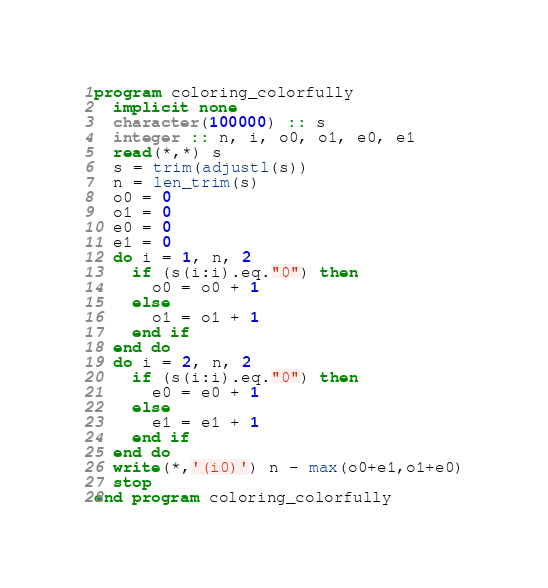<code> <loc_0><loc_0><loc_500><loc_500><_FORTRAN_>program coloring_colorfully
  implicit none
  character(100000) :: s
  integer :: n, i, o0, o1, e0, e1
  read(*,*) s
  s = trim(adjustl(s))
  n = len_trim(s)
  o0 = 0
  o1 = 0
  e0 = 0
  e1 = 0
  do i = 1, n, 2
    if (s(i:i).eq."0") then
      o0 = o0 + 1
    else
      o1 = o1 + 1
    end if
  end do
  do i = 2, n, 2
    if (s(i:i).eq."0") then
      e0 = e0 + 1
    else
      e1 = e1 + 1
    end if
  end do
  write(*,'(i0)') n - max(o0+e1,o1+e0)
  stop
end program coloring_colorfully</code> 